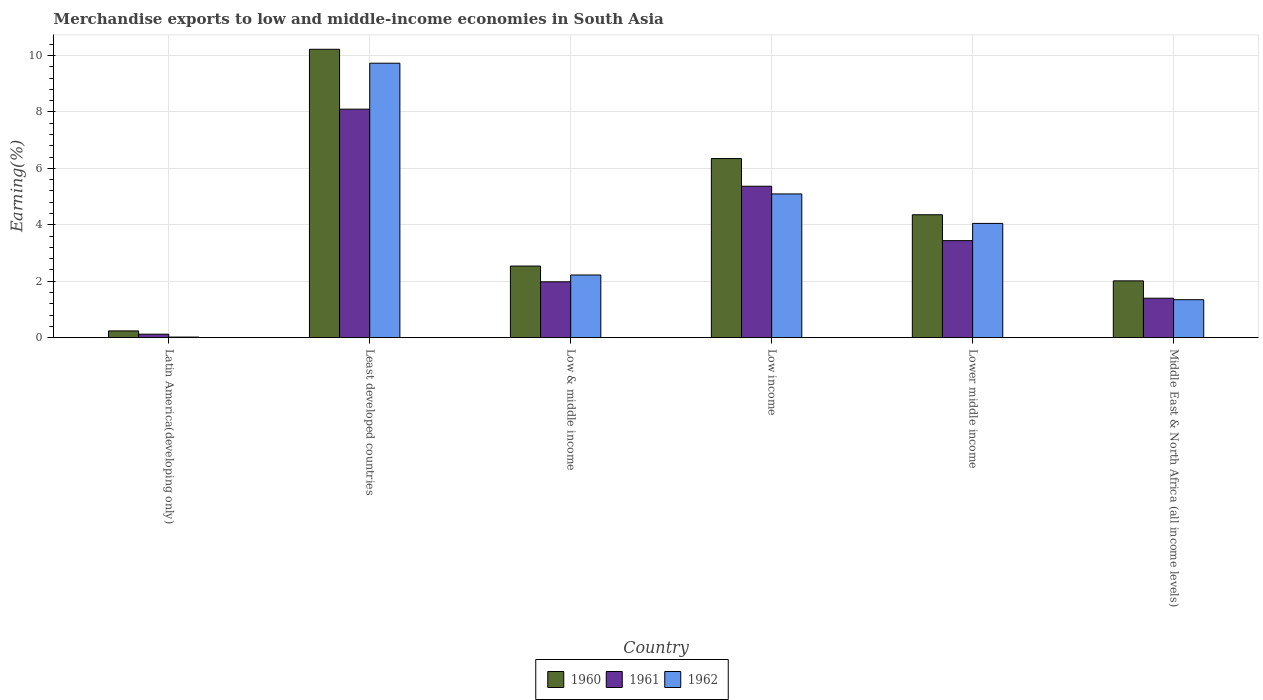How many groups of bars are there?
Offer a very short reply. 6. Are the number of bars on each tick of the X-axis equal?
Offer a very short reply. Yes. How many bars are there on the 4th tick from the left?
Your answer should be compact. 3. What is the percentage of amount earned from merchandise exports in 1961 in Latin America(developing only)?
Your answer should be compact. 0.12. Across all countries, what is the maximum percentage of amount earned from merchandise exports in 1960?
Ensure brevity in your answer.  10.22. Across all countries, what is the minimum percentage of amount earned from merchandise exports in 1962?
Provide a succinct answer. 0.02. In which country was the percentage of amount earned from merchandise exports in 1960 maximum?
Provide a short and direct response. Least developed countries. In which country was the percentage of amount earned from merchandise exports in 1960 minimum?
Your response must be concise. Latin America(developing only). What is the total percentage of amount earned from merchandise exports in 1960 in the graph?
Offer a terse response. 25.71. What is the difference between the percentage of amount earned from merchandise exports in 1961 in Low income and that in Middle East & North Africa (all income levels)?
Offer a very short reply. 3.97. What is the difference between the percentage of amount earned from merchandise exports in 1960 in Low income and the percentage of amount earned from merchandise exports in 1962 in Low & middle income?
Give a very brief answer. 4.13. What is the average percentage of amount earned from merchandise exports in 1960 per country?
Provide a succinct answer. 4.29. What is the difference between the percentage of amount earned from merchandise exports of/in 1962 and percentage of amount earned from merchandise exports of/in 1960 in Low & middle income?
Make the answer very short. -0.32. In how many countries, is the percentage of amount earned from merchandise exports in 1962 greater than 1.6 %?
Offer a terse response. 4. What is the ratio of the percentage of amount earned from merchandise exports in 1960 in Least developed countries to that in Middle East & North Africa (all income levels)?
Make the answer very short. 5.08. Is the difference between the percentage of amount earned from merchandise exports in 1962 in Least developed countries and Middle East & North Africa (all income levels) greater than the difference between the percentage of amount earned from merchandise exports in 1960 in Least developed countries and Middle East & North Africa (all income levels)?
Give a very brief answer. Yes. What is the difference between the highest and the second highest percentage of amount earned from merchandise exports in 1962?
Keep it short and to the point. 5.68. What is the difference between the highest and the lowest percentage of amount earned from merchandise exports in 1960?
Give a very brief answer. 9.98. In how many countries, is the percentage of amount earned from merchandise exports in 1961 greater than the average percentage of amount earned from merchandise exports in 1961 taken over all countries?
Provide a succinct answer. 3. What does the 2nd bar from the left in Low income represents?
Ensure brevity in your answer.  1961. Is it the case that in every country, the sum of the percentage of amount earned from merchandise exports in 1960 and percentage of amount earned from merchandise exports in 1962 is greater than the percentage of amount earned from merchandise exports in 1961?
Offer a very short reply. Yes. How many bars are there?
Your answer should be compact. 18. What is the difference between two consecutive major ticks on the Y-axis?
Give a very brief answer. 2. Are the values on the major ticks of Y-axis written in scientific E-notation?
Your response must be concise. No. Does the graph contain any zero values?
Offer a very short reply. No. Does the graph contain grids?
Your answer should be very brief. Yes. How many legend labels are there?
Provide a short and direct response. 3. What is the title of the graph?
Keep it short and to the point. Merchandise exports to low and middle-income economies in South Asia. Does "1967" appear as one of the legend labels in the graph?
Your answer should be very brief. No. What is the label or title of the X-axis?
Your answer should be compact. Country. What is the label or title of the Y-axis?
Your answer should be very brief. Earning(%). What is the Earning(%) in 1960 in Latin America(developing only)?
Ensure brevity in your answer.  0.24. What is the Earning(%) of 1961 in Latin America(developing only)?
Your response must be concise. 0.12. What is the Earning(%) in 1962 in Latin America(developing only)?
Provide a succinct answer. 0.02. What is the Earning(%) of 1960 in Least developed countries?
Provide a succinct answer. 10.22. What is the Earning(%) of 1961 in Least developed countries?
Your answer should be compact. 8.1. What is the Earning(%) in 1962 in Least developed countries?
Your response must be concise. 9.73. What is the Earning(%) in 1960 in Low & middle income?
Your response must be concise. 2.54. What is the Earning(%) in 1961 in Low & middle income?
Give a very brief answer. 1.98. What is the Earning(%) of 1962 in Low & middle income?
Your answer should be very brief. 2.22. What is the Earning(%) in 1960 in Low income?
Your response must be concise. 6.35. What is the Earning(%) of 1961 in Low income?
Ensure brevity in your answer.  5.37. What is the Earning(%) of 1962 in Low income?
Provide a short and direct response. 5.09. What is the Earning(%) of 1960 in Lower middle income?
Your response must be concise. 4.36. What is the Earning(%) of 1961 in Lower middle income?
Offer a terse response. 3.44. What is the Earning(%) of 1962 in Lower middle income?
Make the answer very short. 4.05. What is the Earning(%) in 1960 in Middle East & North Africa (all income levels)?
Keep it short and to the point. 2.01. What is the Earning(%) of 1961 in Middle East & North Africa (all income levels)?
Ensure brevity in your answer.  1.4. What is the Earning(%) of 1962 in Middle East & North Africa (all income levels)?
Ensure brevity in your answer.  1.35. Across all countries, what is the maximum Earning(%) in 1960?
Your response must be concise. 10.22. Across all countries, what is the maximum Earning(%) in 1961?
Your response must be concise. 8.1. Across all countries, what is the maximum Earning(%) of 1962?
Offer a very short reply. 9.73. Across all countries, what is the minimum Earning(%) in 1960?
Ensure brevity in your answer.  0.24. Across all countries, what is the minimum Earning(%) in 1961?
Offer a terse response. 0.12. Across all countries, what is the minimum Earning(%) in 1962?
Give a very brief answer. 0.02. What is the total Earning(%) of 1960 in the graph?
Ensure brevity in your answer.  25.71. What is the total Earning(%) in 1961 in the graph?
Provide a succinct answer. 20.4. What is the total Earning(%) in 1962 in the graph?
Your answer should be compact. 22.46. What is the difference between the Earning(%) in 1960 in Latin America(developing only) and that in Least developed countries?
Your answer should be very brief. -9.98. What is the difference between the Earning(%) of 1961 in Latin America(developing only) and that in Least developed countries?
Make the answer very short. -7.97. What is the difference between the Earning(%) of 1962 in Latin America(developing only) and that in Least developed countries?
Keep it short and to the point. -9.7. What is the difference between the Earning(%) in 1960 in Latin America(developing only) and that in Low & middle income?
Your response must be concise. -2.3. What is the difference between the Earning(%) of 1961 in Latin America(developing only) and that in Low & middle income?
Make the answer very short. -1.86. What is the difference between the Earning(%) of 1962 in Latin America(developing only) and that in Low & middle income?
Provide a short and direct response. -2.2. What is the difference between the Earning(%) of 1960 in Latin America(developing only) and that in Low income?
Keep it short and to the point. -6.11. What is the difference between the Earning(%) of 1961 in Latin America(developing only) and that in Low income?
Your response must be concise. -5.24. What is the difference between the Earning(%) in 1962 in Latin America(developing only) and that in Low income?
Your response must be concise. -5.07. What is the difference between the Earning(%) in 1960 in Latin America(developing only) and that in Lower middle income?
Ensure brevity in your answer.  -4.12. What is the difference between the Earning(%) in 1961 in Latin America(developing only) and that in Lower middle income?
Provide a succinct answer. -3.31. What is the difference between the Earning(%) in 1962 in Latin America(developing only) and that in Lower middle income?
Offer a very short reply. -4.03. What is the difference between the Earning(%) of 1960 in Latin America(developing only) and that in Middle East & North Africa (all income levels)?
Keep it short and to the point. -1.77. What is the difference between the Earning(%) in 1961 in Latin America(developing only) and that in Middle East & North Africa (all income levels)?
Provide a short and direct response. -1.27. What is the difference between the Earning(%) of 1962 in Latin America(developing only) and that in Middle East & North Africa (all income levels)?
Keep it short and to the point. -1.32. What is the difference between the Earning(%) in 1960 in Least developed countries and that in Low & middle income?
Your answer should be compact. 7.68. What is the difference between the Earning(%) of 1961 in Least developed countries and that in Low & middle income?
Your answer should be very brief. 6.12. What is the difference between the Earning(%) in 1962 in Least developed countries and that in Low & middle income?
Your answer should be compact. 7.5. What is the difference between the Earning(%) of 1960 in Least developed countries and that in Low income?
Offer a terse response. 3.87. What is the difference between the Earning(%) in 1961 in Least developed countries and that in Low income?
Your response must be concise. 2.73. What is the difference between the Earning(%) of 1962 in Least developed countries and that in Low income?
Keep it short and to the point. 4.63. What is the difference between the Earning(%) in 1960 in Least developed countries and that in Lower middle income?
Ensure brevity in your answer.  5.86. What is the difference between the Earning(%) in 1961 in Least developed countries and that in Lower middle income?
Give a very brief answer. 4.66. What is the difference between the Earning(%) of 1962 in Least developed countries and that in Lower middle income?
Keep it short and to the point. 5.68. What is the difference between the Earning(%) of 1960 in Least developed countries and that in Middle East & North Africa (all income levels)?
Give a very brief answer. 8.21. What is the difference between the Earning(%) in 1961 in Least developed countries and that in Middle East & North Africa (all income levels)?
Provide a short and direct response. 6.7. What is the difference between the Earning(%) in 1962 in Least developed countries and that in Middle East & North Africa (all income levels)?
Ensure brevity in your answer.  8.38. What is the difference between the Earning(%) in 1960 in Low & middle income and that in Low income?
Your answer should be very brief. -3.81. What is the difference between the Earning(%) in 1961 in Low & middle income and that in Low income?
Your answer should be compact. -3.39. What is the difference between the Earning(%) of 1962 in Low & middle income and that in Low income?
Make the answer very short. -2.87. What is the difference between the Earning(%) in 1960 in Low & middle income and that in Lower middle income?
Make the answer very short. -1.82. What is the difference between the Earning(%) of 1961 in Low & middle income and that in Lower middle income?
Your response must be concise. -1.46. What is the difference between the Earning(%) of 1962 in Low & middle income and that in Lower middle income?
Your answer should be very brief. -1.83. What is the difference between the Earning(%) of 1960 in Low & middle income and that in Middle East & North Africa (all income levels)?
Ensure brevity in your answer.  0.52. What is the difference between the Earning(%) in 1961 in Low & middle income and that in Middle East & North Africa (all income levels)?
Ensure brevity in your answer.  0.58. What is the difference between the Earning(%) of 1962 in Low & middle income and that in Middle East & North Africa (all income levels)?
Your response must be concise. 0.88. What is the difference between the Earning(%) in 1960 in Low income and that in Lower middle income?
Provide a short and direct response. 1.99. What is the difference between the Earning(%) in 1961 in Low income and that in Lower middle income?
Your response must be concise. 1.93. What is the difference between the Earning(%) in 1962 in Low income and that in Lower middle income?
Your answer should be very brief. 1.04. What is the difference between the Earning(%) in 1960 in Low income and that in Middle East & North Africa (all income levels)?
Your response must be concise. 4.33. What is the difference between the Earning(%) of 1961 in Low income and that in Middle East & North Africa (all income levels)?
Your response must be concise. 3.97. What is the difference between the Earning(%) of 1962 in Low income and that in Middle East & North Africa (all income levels)?
Keep it short and to the point. 3.75. What is the difference between the Earning(%) of 1960 in Lower middle income and that in Middle East & North Africa (all income levels)?
Your response must be concise. 2.34. What is the difference between the Earning(%) of 1961 in Lower middle income and that in Middle East & North Africa (all income levels)?
Your answer should be compact. 2.04. What is the difference between the Earning(%) in 1962 in Lower middle income and that in Middle East & North Africa (all income levels)?
Offer a terse response. 2.7. What is the difference between the Earning(%) of 1960 in Latin America(developing only) and the Earning(%) of 1961 in Least developed countries?
Your response must be concise. -7.86. What is the difference between the Earning(%) in 1960 in Latin America(developing only) and the Earning(%) in 1962 in Least developed countries?
Your answer should be very brief. -9.49. What is the difference between the Earning(%) in 1961 in Latin America(developing only) and the Earning(%) in 1962 in Least developed countries?
Provide a succinct answer. -9.6. What is the difference between the Earning(%) in 1960 in Latin America(developing only) and the Earning(%) in 1961 in Low & middle income?
Offer a very short reply. -1.74. What is the difference between the Earning(%) in 1960 in Latin America(developing only) and the Earning(%) in 1962 in Low & middle income?
Give a very brief answer. -1.98. What is the difference between the Earning(%) in 1961 in Latin America(developing only) and the Earning(%) in 1962 in Low & middle income?
Ensure brevity in your answer.  -2.1. What is the difference between the Earning(%) in 1960 in Latin America(developing only) and the Earning(%) in 1961 in Low income?
Your answer should be very brief. -5.13. What is the difference between the Earning(%) in 1960 in Latin America(developing only) and the Earning(%) in 1962 in Low income?
Make the answer very short. -4.85. What is the difference between the Earning(%) in 1961 in Latin America(developing only) and the Earning(%) in 1962 in Low income?
Make the answer very short. -4.97. What is the difference between the Earning(%) of 1960 in Latin America(developing only) and the Earning(%) of 1961 in Lower middle income?
Provide a succinct answer. -3.2. What is the difference between the Earning(%) of 1960 in Latin America(developing only) and the Earning(%) of 1962 in Lower middle income?
Your response must be concise. -3.81. What is the difference between the Earning(%) in 1961 in Latin America(developing only) and the Earning(%) in 1962 in Lower middle income?
Your answer should be very brief. -3.93. What is the difference between the Earning(%) in 1960 in Latin America(developing only) and the Earning(%) in 1961 in Middle East & North Africa (all income levels)?
Keep it short and to the point. -1.16. What is the difference between the Earning(%) in 1960 in Latin America(developing only) and the Earning(%) in 1962 in Middle East & North Africa (all income levels)?
Your response must be concise. -1.11. What is the difference between the Earning(%) of 1961 in Latin America(developing only) and the Earning(%) of 1962 in Middle East & North Africa (all income levels)?
Give a very brief answer. -1.22. What is the difference between the Earning(%) of 1960 in Least developed countries and the Earning(%) of 1961 in Low & middle income?
Provide a succinct answer. 8.24. What is the difference between the Earning(%) of 1960 in Least developed countries and the Earning(%) of 1962 in Low & middle income?
Keep it short and to the point. 8. What is the difference between the Earning(%) in 1961 in Least developed countries and the Earning(%) in 1962 in Low & middle income?
Keep it short and to the point. 5.88. What is the difference between the Earning(%) of 1960 in Least developed countries and the Earning(%) of 1961 in Low income?
Your response must be concise. 4.85. What is the difference between the Earning(%) in 1960 in Least developed countries and the Earning(%) in 1962 in Low income?
Your answer should be compact. 5.13. What is the difference between the Earning(%) of 1961 in Least developed countries and the Earning(%) of 1962 in Low income?
Keep it short and to the point. 3. What is the difference between the Earning(%) of 1960 in Least developed countries and the Earning(%) of 1961 in Lower middle income?
Keep it short and to the point. 6.78. What is the difference between the Earning(%) in 1960 in Least developed countries and the Earning(%) in 1962 in Lower middle income?
Provide a short and direct response. 6.17. What is the difference between the Earning(%) of 1961 in Least developed countries and the Earning(%) of 1962 in Lower middle income?
Keep it short and to the point. 4.05. What is the difference between the Earning(%) in 1960 in Least developed countries and the Earning(%) in 1961 in Middle East & North Africa (all income levels)?
Make the answer very short. 8.82. What is the difference between the Earning(%) in 1960 in Least developed countries and the Earning(%) in 1962 in Middle East & North Africa (all income levels)?
Give a very brief answer. 8.87. What is the difference between the Earning(%) in 1961 in Least developed countries and the Earning(%) in 1962 in Middle East & North Africa (all income levels)?
Make the answer very short. 6.75. What is the difference between the Earning(%) in 1960 in Low & middle income and the Earning(%) in 1961 in Low income?
Your answer should be very brief. -2.83. What is the difference between the Earning(%) in 1960 in Low & middle income and the Earning(%) in 1962 in Low income?
Offer a terse response. -2.56. What is the difference between the Earning(%) in 1961 in Low & middle income and the Earning(%) in 1962 in Low income?
Provide a short and direct response. -3.11. What is the difference between the Earning(%) in 1960 in Low & middle income and the Earning(%) in 1961 in Lower middle income?
Give a very brief answer. -0.9. What is the difference between the Earning(%) in 1960 in Low & middle income and the Earning(%) in 1962 in Lower middle income?
Provide a short and direct response. -1.51. What is the difference between the Earning(%) of 1961 in Low & middle income and the Earning(%) of 1962 in Lower middle income?
Ensure brevity in your answer.  -2.07. What is the difference between the Earning(%) in 1960 in Low & middle income and the Earning(%) in 1961 in Middle East & North Africa (all income levels)?
Your answer should be very brief. 1.14. What is the difference between the Earning(%) of 1960 in Low & middle income and the Earning(%) of 1962 in Middle East & North Africa (all income levels)?
Your answer should be very brief. 1.19. What is the difference between the Earning(%) of 1961 in Low & middle income and the Earning(%) of 1962 in Middle East & North Africa (all income levels)?
Offer a terse response. 0.63. What is the difference between the Earning(%) in 1960 in Low income and the Earning(%) in 1961 in Lower middle income?
Provide a short and direct response. 2.91. What is the difference between the Earning(%) in 1960 in Low income and the Earning(%) in 1962 in Lower middle income?
Ensure brevity in your answer.  2.3. What is the difference between the Earning(%) in 1961 in Low income and the Earning(%) in 1962 in Lower middle income?
Give a very brief answer. 1.32. What is the difference between the Earning(%) of 1960 in Low income and the Earning(%) of 1961 in Middle East & North Africa (all income levels)?
Keep it short and to the point. 4.95. What is the difference between the Earning(%) in 1960 in Low income and the Earning(%) in 1962 in Middle East & North Africa (all income levels)?
Offer a very short reply. 5. What is the difference between the Earning(%) in 1961 in Low income and the Earning(%) in 1962 in Middle East & North Africa (all income levels)?
Ensure brevity in your answer.  4.02. What is the difference between the Earning(%) of 1960 in Lower middle income and the Earning(%) of 1961 in Middle East & North Africa (all income levels)?
Provide a short and direct response. 2.96. What is the difference between the Earning(%) in 1960 in Lower middle income and the Earning(%) in 1962 in Middle East & North Africa (all income levels)?
Give a very brief answer. 3.01. What is the difference between the Earning(%) in 1961 in Lower middle income and the Earning(%) in 1962 in Middle East & North Africa (all income levels)?
Offer a terse response. 2.09. What is the average Earning(%) in 1960 per country?
Make the answer very short. 4.29. What is the average Earning(%) in 1961 per country?
Your answer should be very brief. 3.4. What is the average Earning(%) in 1962 per country?
Your answer should be very brief. 3.74. What is the difference between the Earning(%) of 1960 and Earning(%) of 1961 in Latin America(developing only)?
Keep it short and to the point. 0.12. What is the difference between the Earning(%) in 1960 and Earning(%) in 1962 in Latin America(developing only)?
Give a very brief answer. 0.22. What is the difference between the Earning(%) in 1961 and Earning(%) in 1962 in Latin America(developing only)?
Offer a terse response. 0.1. What is the difference between the Earning(%) in 1960 and Earning(%) in 1961 in Least developed countries?
Give a very brief answer. 2.12. What is the difference between the Earning(%) in 1960 and Earning(%) in 1962 in Least developed countries?
Offer a terse response. 0.49. What is the difference between the Earning(%) of 1961 and Earning(%) of 1962 in Least developed countries?
Ensure brevity in your answer.  -1.63. What is the difference between the Earning(%) in 1960 and Earning(%) in 1961 in Low & middle income?
Your answer should be very brief. 0.56. What is the difference between the Earning(%) in 1960 and Earning(%) in 1962 in Low & middle income?
Your answer should be compact. 0.32. What is the difference between the Earning(%) in 1961 and Earning(%) in 1962 in Low & middle income?
Provide a short and direct response. -0.24. What is the difference between the Earning(%) in 1960 and Earning(%) in 1961 in Low income?
Give a very brief answer. 0.98. What is the difference between the Earning(%) in 1960 and Earning(%) in 1962 in Low income?
Provide a succinct answer. 1.25. What is the difference between the Earning(%) in 1961 and Earning(%) in 1962 in Low income?
Make the answer very short. 0.27. What is the difference between the Earning(%) in 1960 and Earning(%) in 1961 in Lower middle income?
Provide a succinct answer. 0.92. What is the difference between the Earning(%) of 1960 and Earning(%) of 1962 in Lower middle income?
Keep it short and to the point. 0.31. What is the difference between the Earning(%) of 1961 and Earning(%) of 1962 in Lower middle income?
Ensure brevity in your answer.  -0.61. What is the difference between the Earning(%) in 1960 and Earning(%) in 1961 in Middle East & North Africa (all income levels)?
Make the answer very short. 0.62. What is the difference between the Earning(%) in 1960 and Earning(%) in 1962 in Middle East & North Africa (all income levels)?
Your answer should be compact. 0.67. What is the difference between the Earning(%) in 1961 and Earning(%) in 1962 in Middle East & North Africa (all income levels)?
Your answer should be compact. 0.05. What is the ratio of the Earning(%) of 1960 in Latin America(developing only) to that in Least developed countries?
Offer a terse response. 0.02. What is the ratio of the Earning(%) of 1961 in Latin America(developing only) to that in Least developed countries?
Your answer should be compact. 0.02. What is the ratio of the Earning(%) in 1962 in Latin America(developing only) to that in Least developed countries?
Your response must be concise. 0. What is the ratio of the Earning(%) in 1960 in Latin America(developing only) to that in Low & middle income?
Your answer should be very brief. 0.09. What is the ratio of the Earning(%) of 1961 in Latin America(developing only) to that in Low & middle income?
Your answer should be very brief. 0.06. What is the ratio of the Earning(%) of 1962 in Latin America(developing only) to that in Low & middle income?
Ensure brevity in your answer.  0.01. What is the ratio of the Earning(%) of 1960 in Latin America(developing only) to that in Low income?
Provide a short and direct response. 0.04. What is the ratio of the Earning(%) of 1961 in Latin America(developing only) to that in Low income?
Provide a short and direct response. 0.02. What is the ratio of the Earning(%) in 1962 in Latin America(developing only) to that in Low income?
Offer a terse response. 0. What is the ratio of the Earning(%) of 1960 in Latin America(developing only) to that in Lower middle income?
Your response must be concise. 0.05. What is the ratio of the Earning(%) of 1961 in Latin America(developing only) to that in Lower middle income?
Your response must be concise. 0.04. What is the ratio of the Earning(%) in 1962 in Latin America(developing only) to that in Lower middle income?
Provide a short and direct response. 0.01. What is the ratio of the Earning(%) in 1960 in Latin America(developing only) to that in Middle East & North Africa (all income levels)?
Your response must be concise. 0.12. What is the ratio of the Earning(%) in 1961 in Latin America(developing only) to that in Middle East & North Africa (all income levels)?
Provide a short and direct response. 0.09. What is the ratio of the Earning(%) of 1962 in Latin America(developing only) to that in Middle East & North Africa (all income levels)?
Your answer should be very brief. 0.02. What is the ratio of the Earning(%) of 1960 in Least developed countries to that in Low & middle income?
Offer a terse response. 4.03. What is the ratio of the Earning(%) of 1961 in Least developed countries to that in Low & middle income?
Give a very brief answer. 4.09. What is the ratio of the Earning(%) of 1962 in Least developed countries to that in Low & middle income?
Your response must be concise. 4.38. What is the ratio of the Earning(%) in 1960 in Least developed countries to that in Low income?
Your answer should be compact. 1.61. What is the ratio of the Earning(%) in 1961 in Least developed countries to that in Low income?
Provide a short and direct response. 1.51. What is the ratio of the Earning(%) of 1962 in Least developed countries to that in Low income?
Your response must be concise. 1.91. What is the ratio of the Earning(%) in 1960 in Least developed countries to that in Lower middle income?
Your answer should be very brief. 2.35. What is the ratio of the Earning(%) of 1961 in Least developed countries to that in Lower middle income?
Your answer should be very brief. 2.36. What is the ratio of the Earning(%) of 1962 in Least developed countries to that in Lower middle income?
Provide a short and direct response. 2.4. What is the ratio of the Earning(%) of 1960 in Least developed countries to that in Middle East & North Africa (all income levels)?
Ensure brevity in your answer.  5.08. What is the ratio of the Earning(%) of 1961 in Least developed countries to that in Middle East & North Africa (all income levels)?
Provide a short and direct response. 5.79. What is the ratio of the Earning(%) of 1962 in Least developed countries to that in Middle East & North Africa (all income levels)?
Provide a short and direct response. 7.23. What is the ratio of the Earning(%) in 1960 in Low & middle income to that in Low income?
Give a very brief answer. 0.4. What is the ratio of the Earning(%) of 1961 in Low & middle income to that in Low income?
Offer a very short reply. 0.37. What is the ratio of the Earning(%) in 1962 in Low & middle income to that in Low income?
Your answer should be very brief. 0.44. What is the ratio of the Earning(%) in 1960 in Low & middle income to that in Lower middle income?
Provide a succinct answer. 0.58. What is the ratio of the Earning(%) in 1961 in Low & middle income to that in Lower middle income?
Provide a succinct answer. 0.58. What is the ratio of the Earning(%) in 1962 in Low & middle income to that in Lower middle income?
Keep it short and to the point. 0.55. What is the ratio of the Earning(%) of 1960 in Low & middle income to that in Middle East & North Africa (all income levels)?
Ensure brevity in your answer.  1.26. What is the ratio of the Earning(%) in 1961 in Low & middle income to that in Middle East & North Africa (all income levels)?
Your answer should be very brief. 1.42. What is the ratio of the Earning(%) in 1962 in Low & middle income to that in Middle East & North Africa (all income levels)?
Your response must be concise. 1.65. What is the ratio of the Earning(%) of 1960 in Low income to that in Lower middle income?
Provide a short and direct response. 1.46. What is the ratio of the Earning(%) in 1961 in Low income to that in Lower middle income?
Provide a succinct answer. 1.56. What is the ratio of the Earning(%) of 1962 in Low income to that in Lower middle income?
Offer a terse response. 1.26. What is the ratio of the Earning(%) in 1960 in Low income to that in Middle East & North Africa (all income levels)?
Provide a succinct answer. 3.15. What is the ratio of the Earning(%) in 1961 in Low income to that in Middle East & North Africa (all income levels)?
Keep it short and to the point. 3.84. What is the ratio of the Earning(%) in 1962 in Low income to that in Middle East & North Africa (all income levels)?
Make the answer very short. 3.78. What is the ratio of the Earning(%) in 1960 in Lower middle income to that in Middle East & North Africa (all income levels)?
Your answer should be compact. 2.16. What is the ratio of the Earning(%) in 1961 in Lower middle income to that in Middle East & North Africa (all income levels)?
Provide a succinct answer. 2.46. What is the ratio of the Earning(%) of 1962 in Lower middle income to that in Middle East & North Africa (all income levels)?
Keep it short and to the point. 3.01. What is the difference between the highest and the second highest Earning(%) of 1960?
Provide a short and direct response. 3.87. What is the difference between the highest and the second highest Earning(%) in 1961?
Your answer should be very brief. 2.73. What is the difference between the highest and the second highest Earning(%) of 1962?
Ensure brevity in your answer.  4.63. What is the difference between the highest and the lowest Earning(%) of 1960?
Your answer should be compact. 9.98. What is the difference between the highest and the lowest Earning(%) of 1961?
Your answer should be very brief. 7.97. What is the difference between the highest and the lowest Earning(%) of 1962?
Provide a short and direct response. 9.7. 